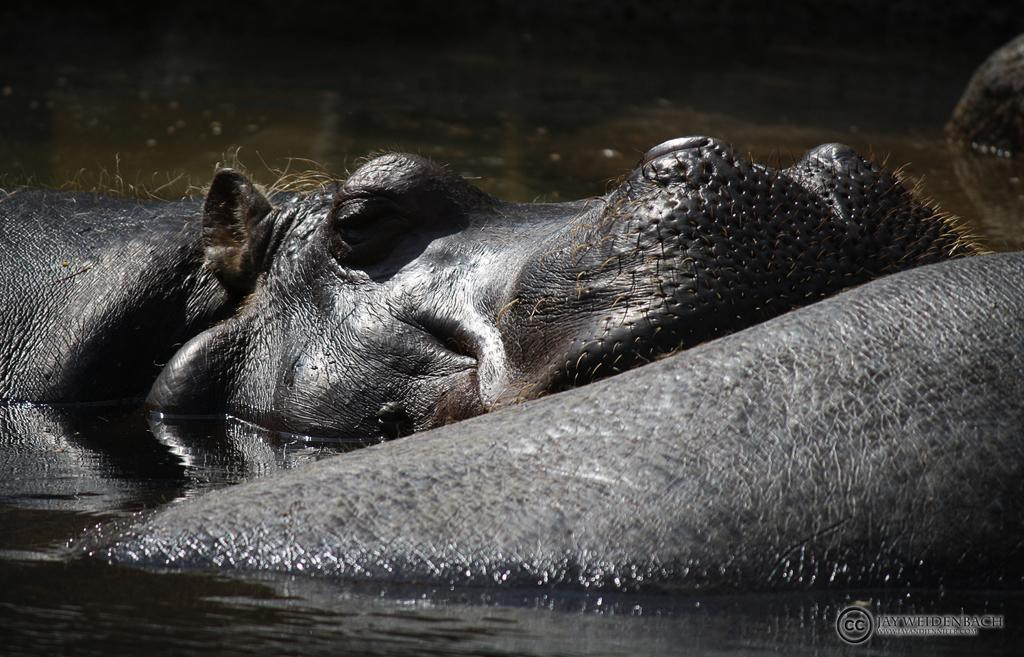What type of animal is in the image? There is a hippopotamus in the image. Where is the animal located in the image? The animal is in the water in the image. Is there any text present in the image? Yes, there is text in the bottom right side of the image. What type of language is spoken by the hippopotamus in the image? There is no indication in the image that the hippopotamus is speaking any language. 